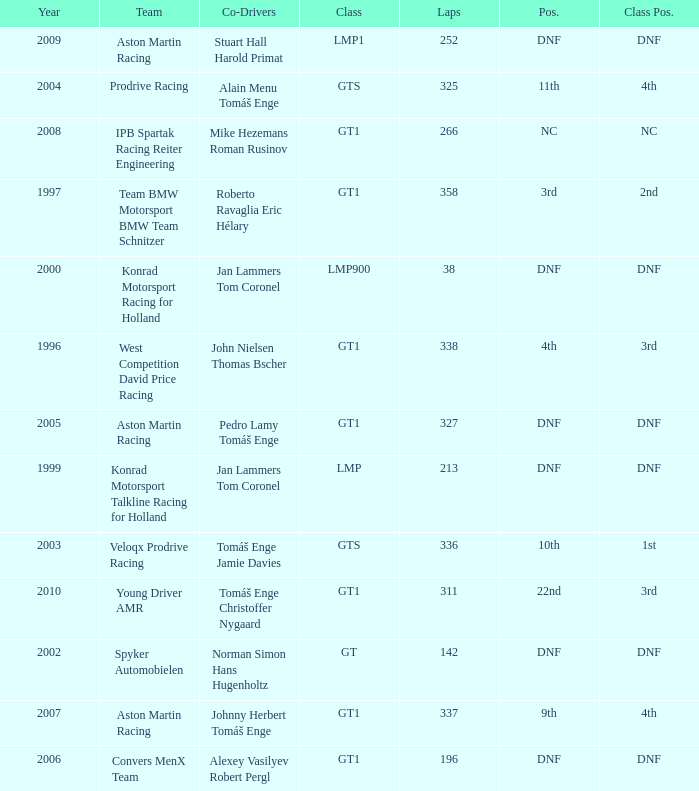Which position finished 3rd in class and completed less than 338 laps? 22nd. Parse the table in full. {'header': ['Year', 'Team', 'Co-Drivers', 'Class', 'Laps', 'Pos.', 'Class Pos.'], 'rows': [['2009', 'Aston Martin Racing', 'Stuart Hall Harold Primat', 'LMP1', '252', 'DNF', 'DNF'], ['2004', 'Prodrive Racing', 'Alain Menu Tomáš Enge', 'GTS', '325', '11th', '4th'], ['2008', 'IPB Spartak Racing Reiter Engineering', 'Mike Hezemans Roman Rusinov', 'GT1', '266', 'NC', 'NC'], ['1997', 'Team BMW Motorsport BMW Team Schnitzer', 'Roberto Ravaglia Eric Hélary', 'GT1', '358', '3rd', '2nd'], ['2000', 'Konrad Motorsport Racing for Holland', 'Jan Lammers Tom Coronel', 'LMP900', '38', 'DNF', 'DNF'], ['1996', 'West Competition David Price Racing', 'John Nielsen Thomas Bscher', 'GT1', '338', '4th', '3rd'], ['2005', 'Aston Martin Racing', 'Pedro Lamy Tomáš Enge', 'GT1', '327', 'DNF', 'DNF'], ['1999', 'Konrad Motorsport Talkline Racing for Holland', 'Jan Lammers Tom Coronel', 'LMP', '213', 'DNF', 'DNF'], ['2003', 'Veloqx Prodrive Racing', 'Tomáš Enge Jamie Davies', 'GTS', '336', '10th', '1st'], ['2010', 'Young Driver AMR', 'Tomáš Enge Christoffer Nygaard', 'GT1', '311', '22nd', '3rd'], ['2002', 'Spyker Automobielen', 'Norman Simon Hans Hugenholtz', 'GT', '142', 'DNF', 'DNF'], ['2007', 'Aston Martin Racing', 'Johnny Herbert Tomáš Enge', 'GT1', '337', '9th', '4th'], ['2006', 'Convers MenX Team', 'Alexey Vasilyev Robert Pergl', 'GT1', '196', 'DNF', 'DNF']]} 